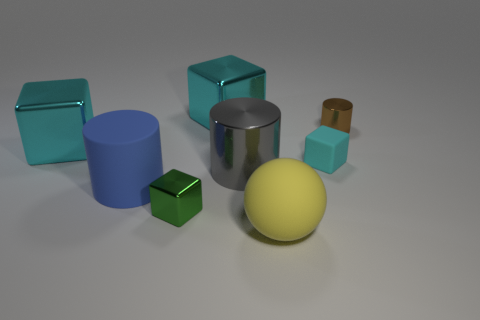Subtract all rubber blocks. How many blocks are left? 3 Add 1 big spheres. How many objects exist? 9 Subtract all green cubes. How many cubes are left? 3 Subtract 2 cylinders. How many cylinders are left? 1 Subtract all cyan balls. How many cyan cubes are left? 3 Add 4 tiny green shiny blocks. How many tiny green shiny blocks exist? 5 Subtract 0 brown cubes. How many objects are left? 8 Subtract all cylinders. How many objects are left? 5 Subtract all red balls. Subtract all green cylinders. How many balls are left? 1 Subtract all tiny cylinders. Subtract all large yellow spheres. How many objects are left? 6 